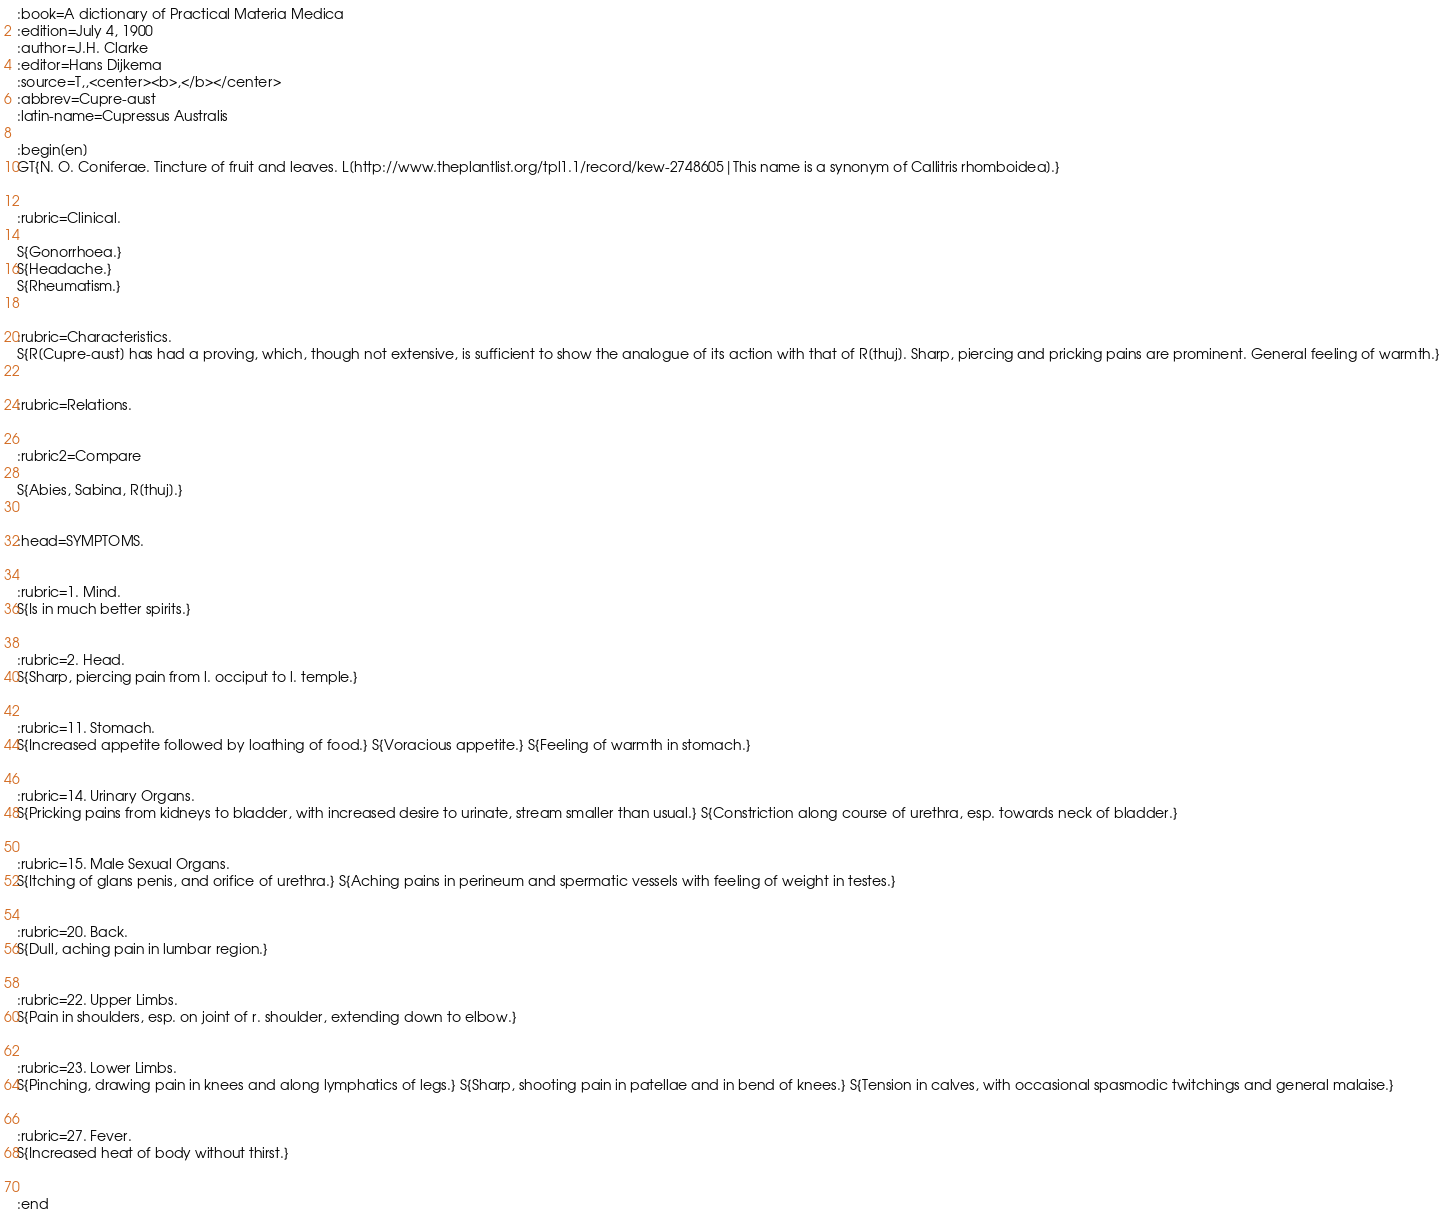<code> <loc_0><loc_0><loc_500><loc_500><_ObjectiveC_>:book=A dictionary of Practical Materia Medica
:edition=July 4, 1900
:author=J.H. Clarke
:editor=Hans Dijkema
:source=T,,<center><b>,</b></center>
:abbrev=Cupre-aust
:latin-name=Cupressus Australis

:begin[en]
GT{N. O. Coniferae. Tincture of fruit and leaves. L[http://www.theplantlist.org/tpl1.1/record/kew-2748605|This name is a synonym of Callitris rhomboidea].}


:rubric=Clinical.

S{Gonorrhoea.}
S{Headache.}
S{Rheumatism.}


:rubric=Characteristics.
S{R[Cupre-aust] has had a proving, which, though not extensive, is sufficient to show the analogue of its action with that of R[thuj]. Sharp, piercing and pricking pains are prominent. General feeling of warmth.}


:rubric=Relations.


:rubric2=Compare

S{Abies, Sabina, R[thuj].}


:head=SYMPTOMS.


:rubric=1. Mind.
S{Is in much better spirits.}


:rubric=2. Head.
S{Sharp, piercing pain from l. occiput to l. temple.}


:rubric=11. Stomach.
S{Increased appetite followed by loathing of food.} S{Voracious appetite.} S{Feeling of warmth in stomach.}


:rubric=14. Urinary Organs.
S{Pricking pains from kidneys to bladder, with increased desire to urinate, stream smaller than usual.} S{Constriction along course of urethra, esp. towards neck of bladder.}


:rubric=15. Male Sexual Organs.
S{Itching of glans penis, and orifice of urethra.} S{Aching pains in perineum and spermatic vessels with feeling of weight in testes.}


:rubric=20. Back.
S{Dull, aching pain in lumbar region.}


:rubric=22. Upper Limbs.
S{Pain in shoulders, esp. on joint of r. shoulder, extending down to elbow.}


:rubric=23. Lower Limbs.
S{Pinching, drawing pain in knees and along lymphatics of legs.} S{Sharp, shooting pain in patellae and in bend of knees.} S{Tension in calves, with occasional spasmodic twitchings and general malaise.}


:rubric=27. Fever.
S{Increased heat of body without thirst.}

  
:end</code> 